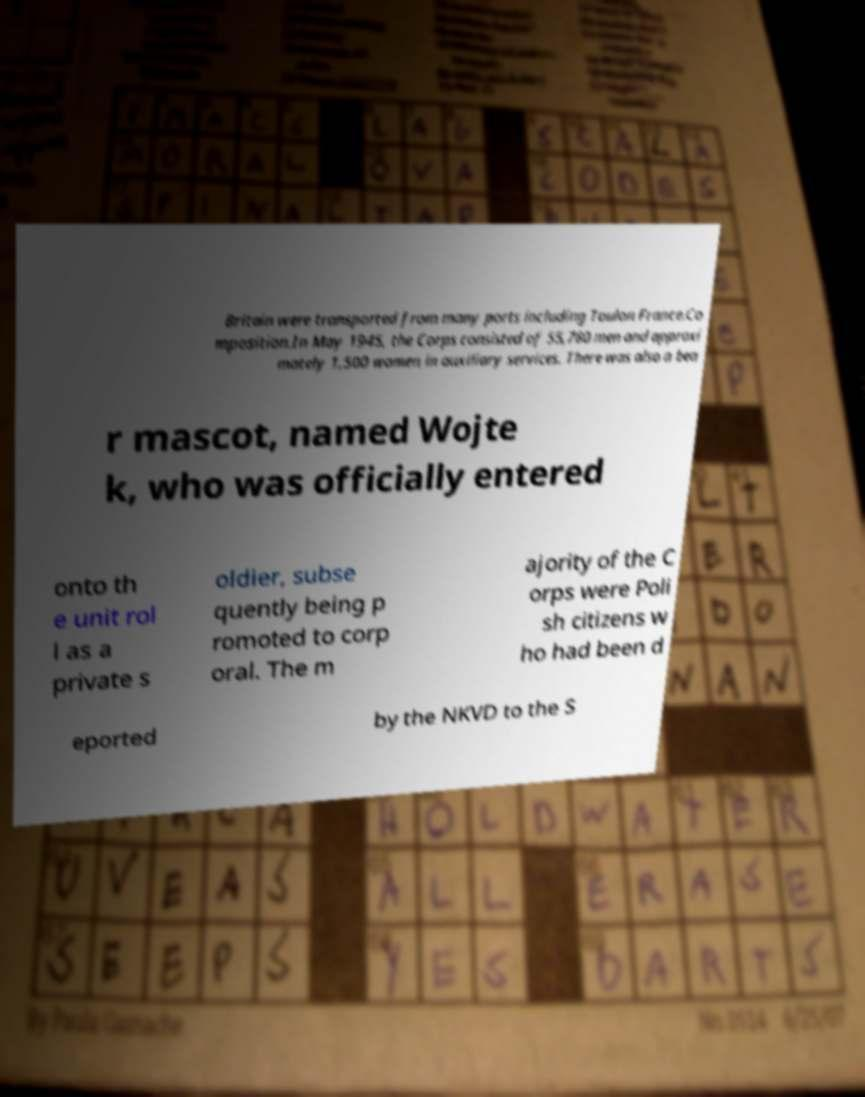Please read and relay the text visible in this image. What does it say? Britain were transported from many ports including Toulon France.Co mposition.In May 1945, the Corps consisted of 55,780 men and approxi mately 1,500 women in auxiliary services. There was also a bea r mascot, named Wojte k, who was officially entered onto th e unit rol l as a private s oldier, subse quently being p romoted to corp oral. The m ajority of the C orps were Poli sh citizens w ho had been d eported by the NKVD to the S 